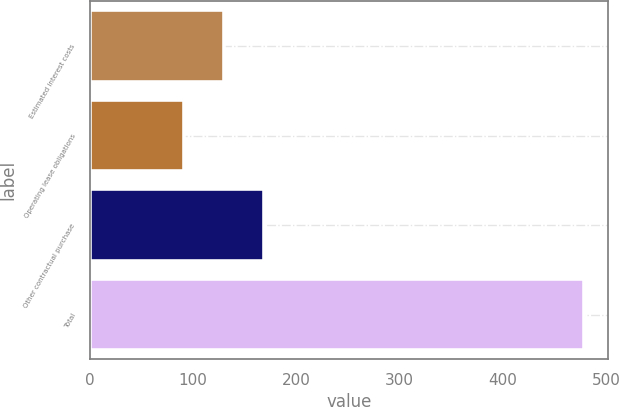Convert chart. <chart><loc_0><loc_0><loc_500><loc_500><bar_chart><fcel>Estimated interest costs<fcel>Operating lease obligations<fcel>Other contractual purchase<fcel>Total<nl><fcel>129.7<fcel>91<fcel>168.4<fcel>478<nl></chart> 